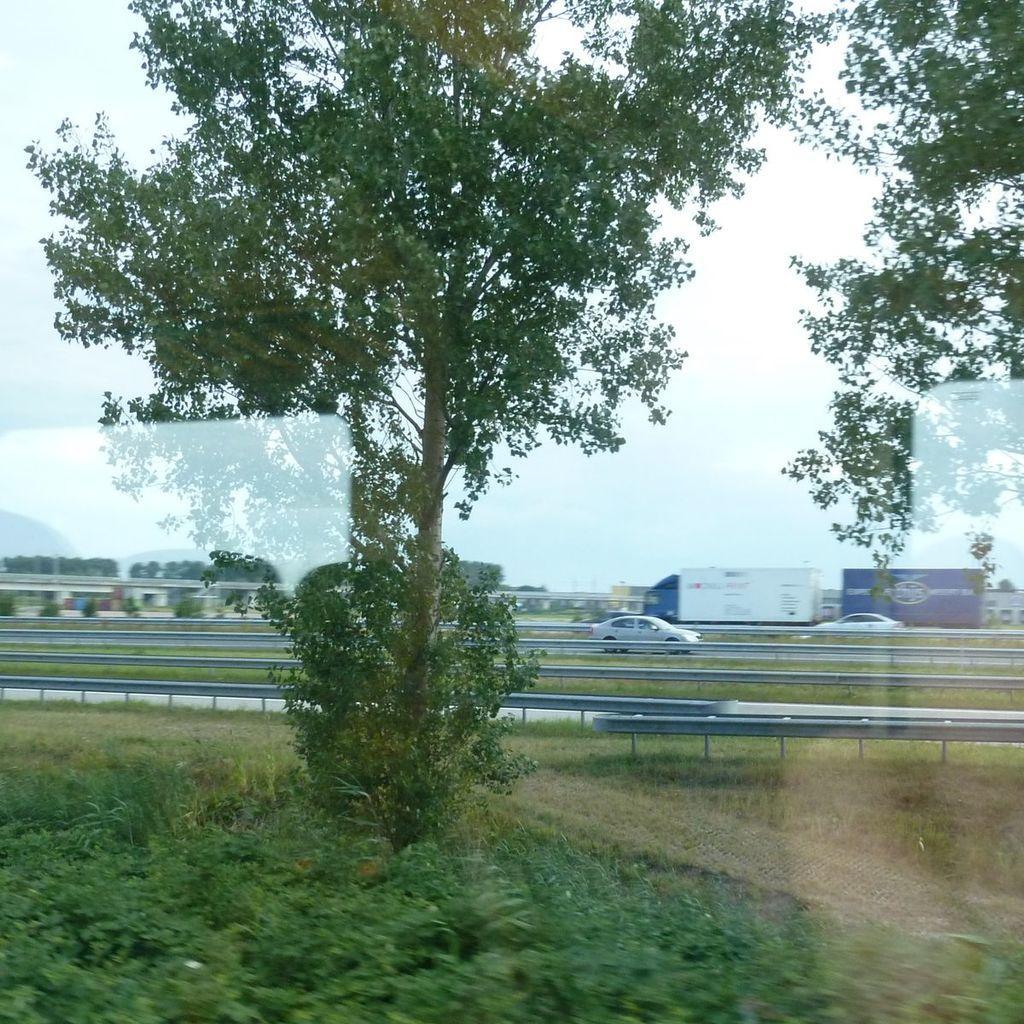How would you summarize this image in a sentence or two? In this picture we can see a tree in the middle, at the bottom there are some plants and grass, we can see two cars and a vehicle in the background, there is the sky at the top of the picture. 